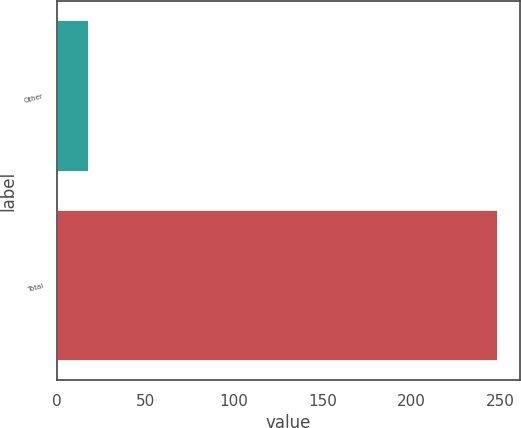Convert chart. <chart><loc_0><loc_0><loc_500><loc_500><bar_chart><fcel>Other<fcel>Total<nl><fcel>18<fcel>249<nl></chart> 